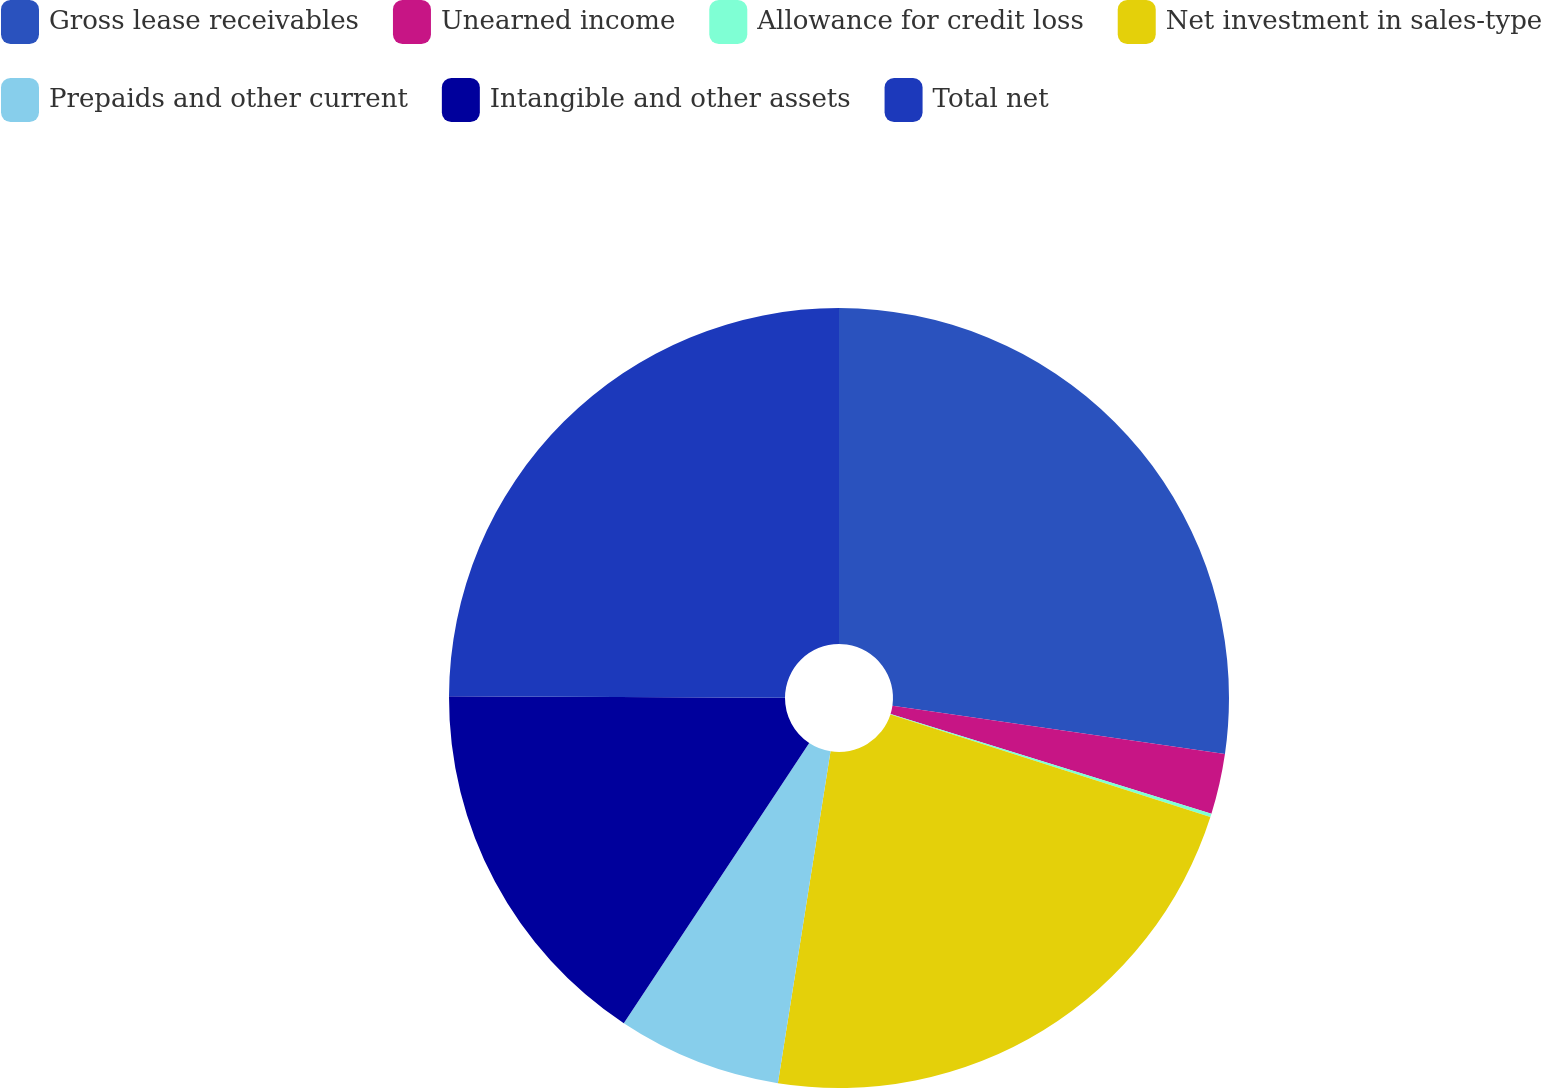Convert chart to OTSL. <chart><loc_0><loc_0><loc_500><loc_500><pie_chart><fcel>Gross lease receivables<fcel>Unearned income<fcel>Allowance for credit loss<fcel>Net investment in sales-type<fcel>Prepaids and other current<fcel>Intangible and other assets<fcel>Total net<nl><fcel>27.3%<fcel>2.5%<fcel>0.14%<fcel>22.57%<fcel>6.8%<fcel>15.77%<fcel>24.93%<nl></chart> 